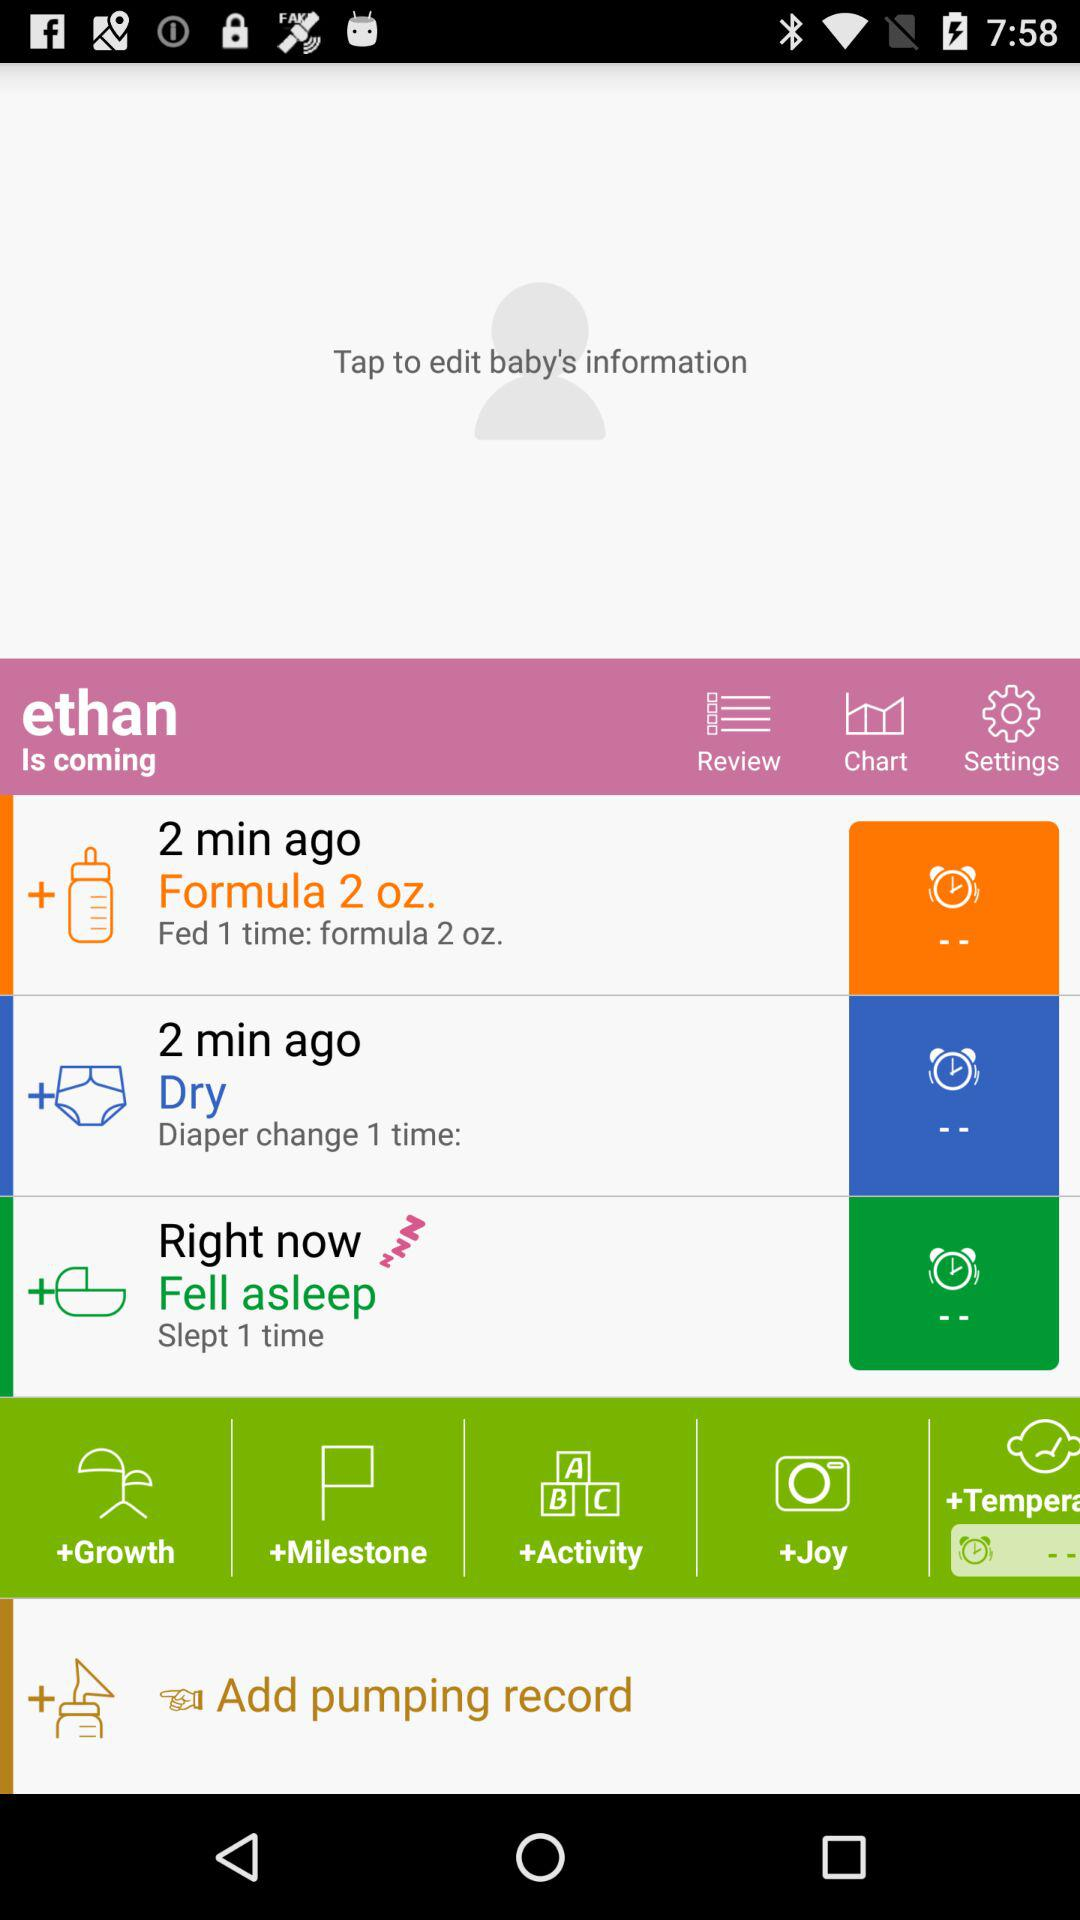What is the condition of the "Right now"? The condition is "Fell asleep". 